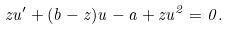<formula> <loc_0><loc_0><loc_500><loc_500>z u ^ { \prime } + ( b - z ) u - a + z u ^ { 2 } = 0 .</formula> 